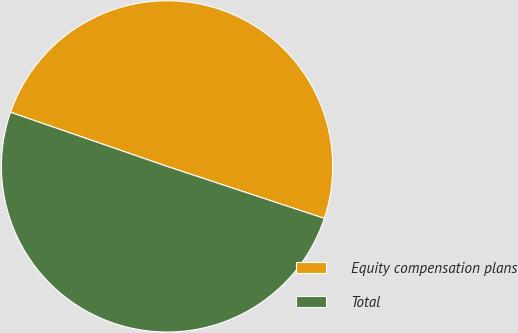<chart> <loc_0><loc_0><loc_500><loc_500><pie_chart><fcel>Equity compensation plans<fcel>Total<nl><fcel>49.79%<fcel>50.21%<nl></chart> 